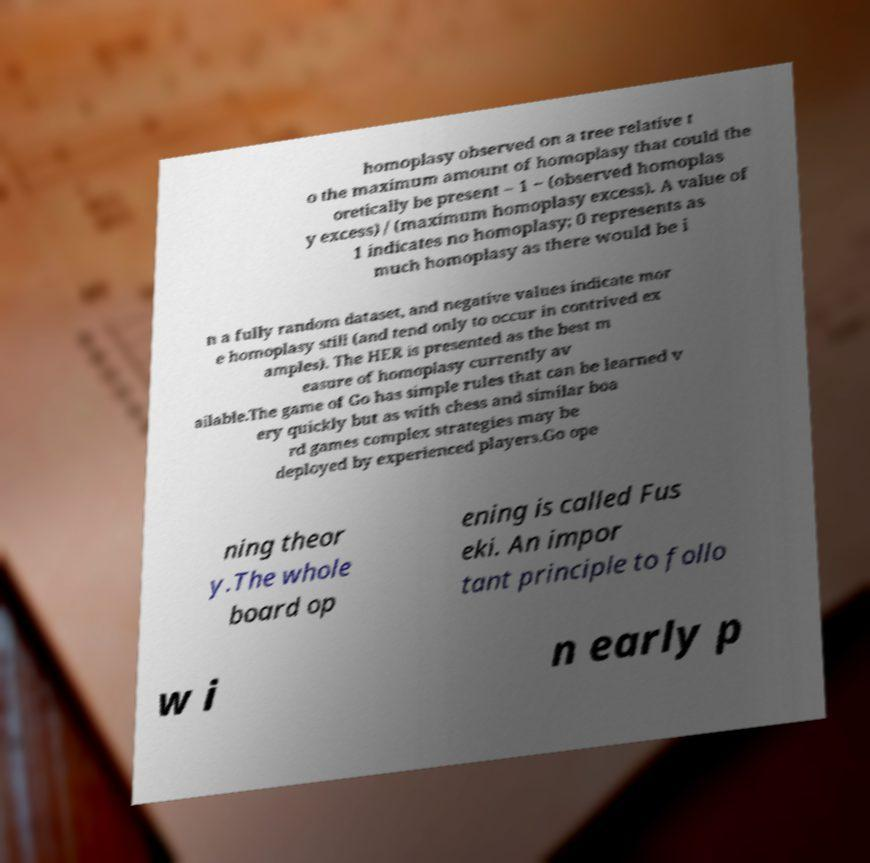I need the written content from this picture converted into text. Can you do that? homoplasy observed on a tree relative t o the maximum amount of homoplasy that could the oretically be present – 1 − (observed homoplas y excess) / (maximum homoplasy excess). A value of 1 indicates no homoplasy; 0 represents as much homoplasy as there would be i n a fully random dataset, and negative values indicate mor e homoplasy still (and tend only to occur in contrived ex amples). The HER is presented as the best m easure of homoplasy currently av ailable.The game of Go has simple rules that can be learned v ery quickly but as with chess and similar boa rd games complex strategies may be deployed by experienced players.Go ope ning theor y.The whole board op ening is called Fus eki. An impor tant principle to follo w i n early p 